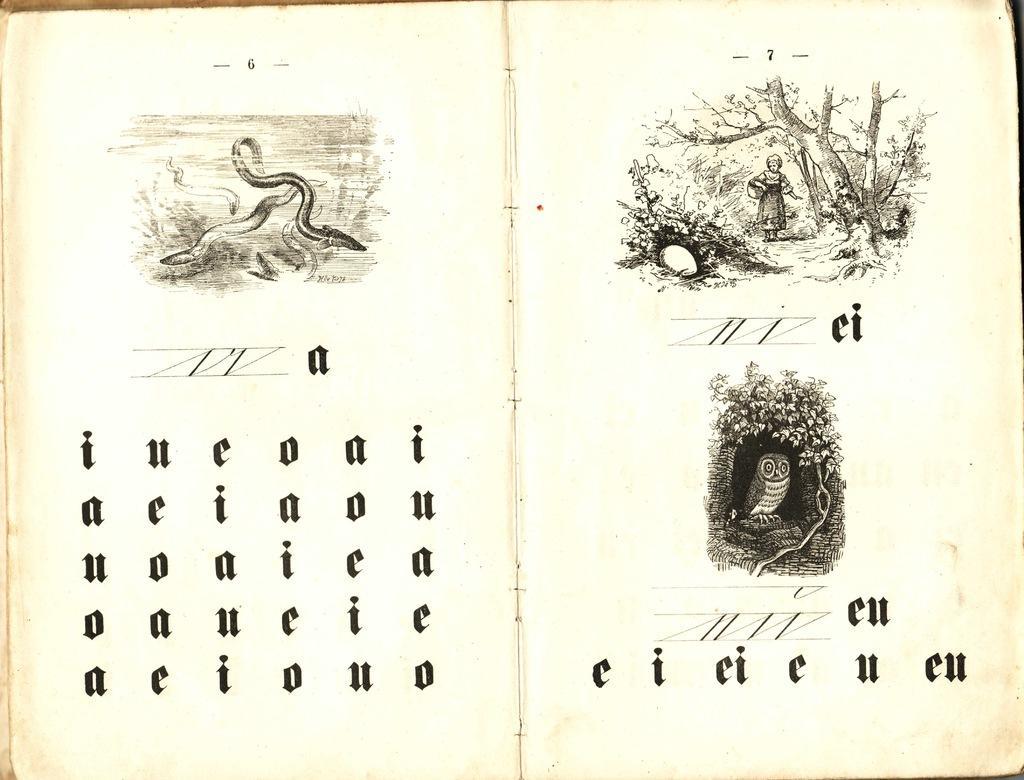How would you summarize this image in a sentence or two? In this image there is a book, on that book there is some text and some pictures. 